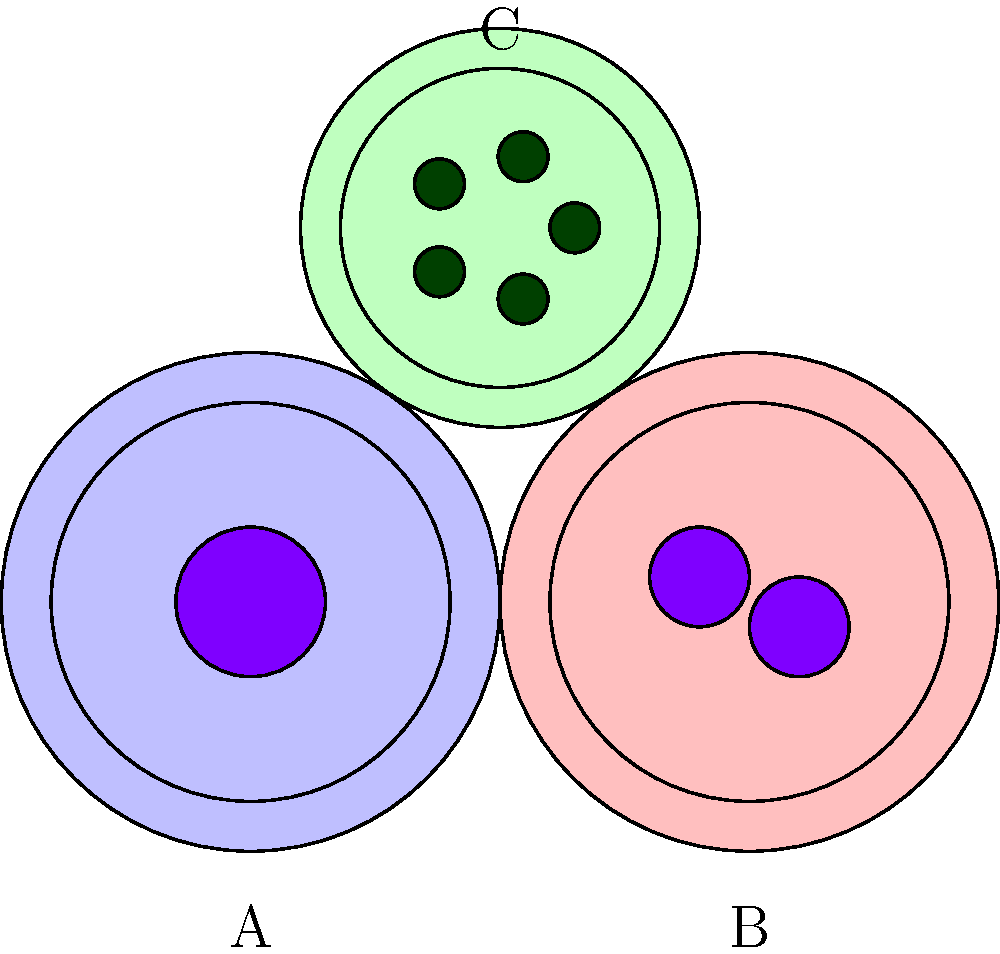In the microscope slide image above, which cell type is most likely to be a granulocyte? To identify the granulocyte, let's analyze each cell type:

1. Cell A:
   - Large, round cell with a single, centrally located nucleus
   - No visible granules in the cytoplasm
   - This appears to be a typical lymphocyte

2. Cell B:
   - Large cell with two distinct nuclei
   - No visible granules in the cytoplasm
   - This resembles a binucleated cell, possibly a megakaryocyte precursor

3. Cell C:
   - Slightly smaller cell with a single nucleus
   - Contains multiple dark-staining granules in the cytoplasm
   - This matches the characteristics of a granulocyte

Granulocytes are white blood cells characterized by the presence of granules in their cytoplasm. These granules contain various enzymes and proteins important for immune function. The most common types of granulocytes are neutrophils, eosinophils, and basophils.

Based on the presence of visible granules in the cytoplasm, Cell C is most likely to be a granulocyte.
Answer: Cell C 